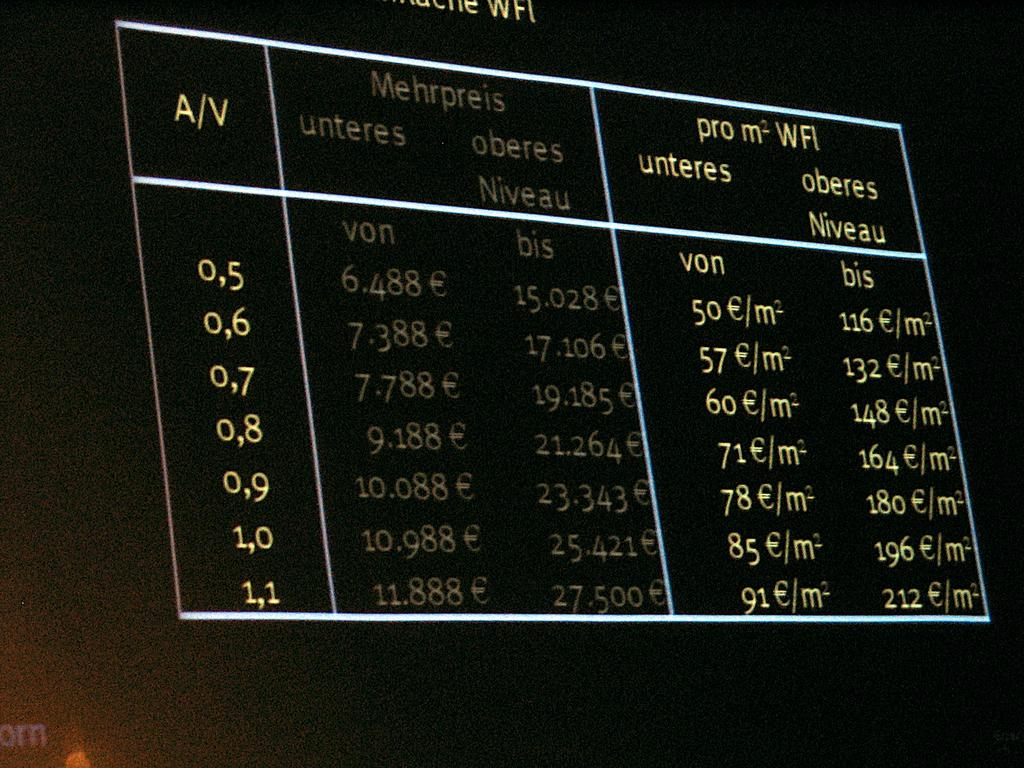<image>
Write a terse but informative summary of the picture. Black background with a chart on it that says Mehrpreis on the top. 